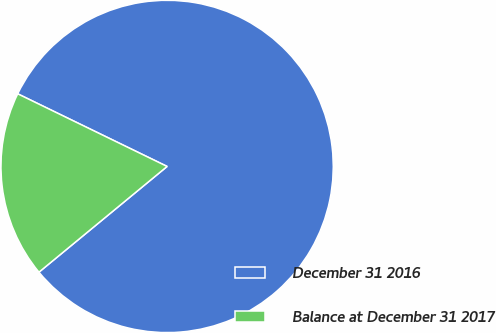Convert chart to OTSL. <chart><loc_0><loc_0><loc_500><loc_500><pie_chart><fcel>December 31 2016<fcel>Balance at December 31 2017<nl><fcel>81.82%<fcel>18.18%<nl></chart> 